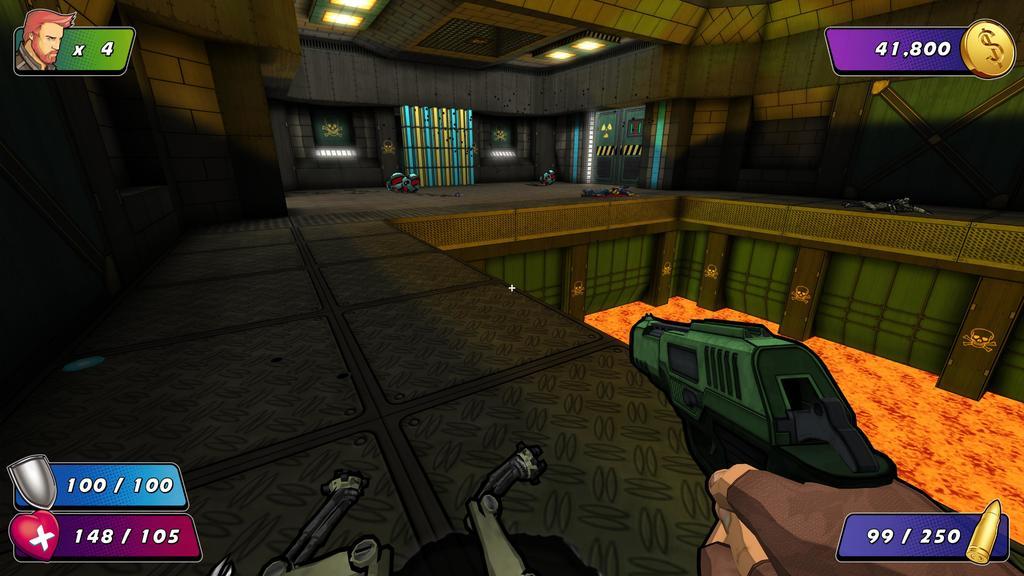In one or two sentences, can you explain what this image depicts? Here we can see an animated picture. There are lights, cartoon images, wall, and ceiling. Here we can see hands of a person holding a gun. 